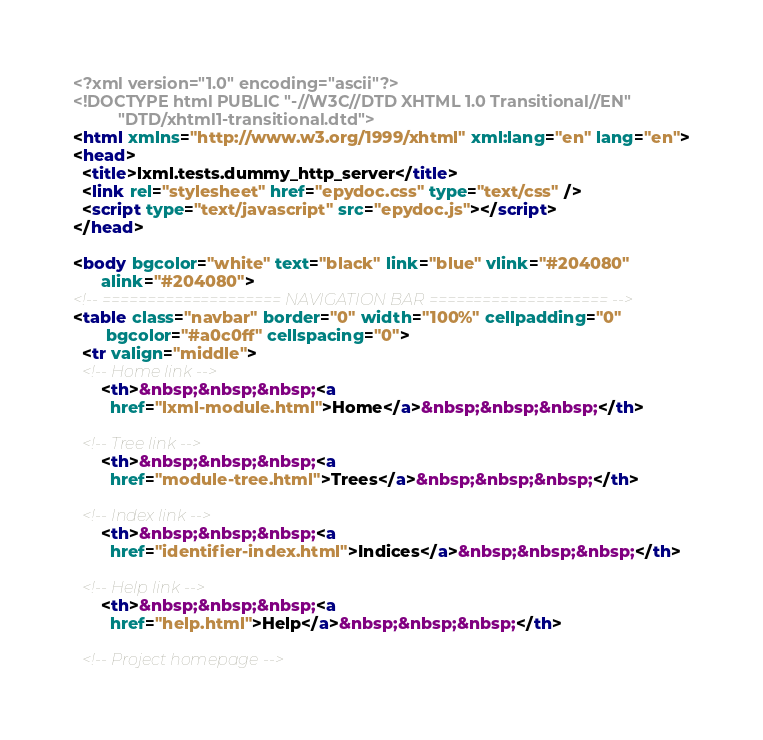Convert code to text. <code><loc_0><loc_0><loc_500><loc_500><_HTML_><?xml version="1.0" encoding="ascii"?>
<!DOCTYPE html PUBLIC "-//W3C//DTD XHTML 1.0 Transitional//EN"
          "DTD/xhtml1-transitional.dtd">
<html xmlns="http://www.w3.org/1999/xhtml" xml:lang="en" lang="en">
<head>
  <title>lxml.tests.dummy_http_server</title>
  <link rel="stylesheet" href="epydoc.css" type="text/css" />
  <script type="text/javascript" src="epydoc.js"></script>
</head>

<body bgcolor="white" text="black" link="blue" vlink="#204080"
      alink="#204080">
<!-- ==================== NAVIGATION BAR ==================== -->
<table class="navbar" border="0" width="100%" cellpadding="0"
       bgcolor="#a0c0ff" cellspacing="0">
  <tr valign="middle">
  <!-- Home link -->
      <th>&nbsp;&nbsp;&nbsp;<a
        href="lxml-module.html">Home</a>&nbsp;&nbsp;&nbsp;</th>

  <!-- Tree link -->
      <th>&nbsp;&nbsp;&nbsp;<a
        href="module-tree.html">Trees</a>&nbsp;&nbsp;&nbsp;</th>

  <!-- Index link -->
      <th>&nbsp;&nbsp;&nbsp;<a
        href="identifier-index.html">Indices</a>&nbsp;&nbsp;&nbsp;</th>

  <!-- Help link -->
      <th>&nbsp;&nbsp;&nbsp;<a
        href="help.html">Help</a>&nbsp;&nbsp;&nbsp;</th>

  <!-- Project homepage --></code> 